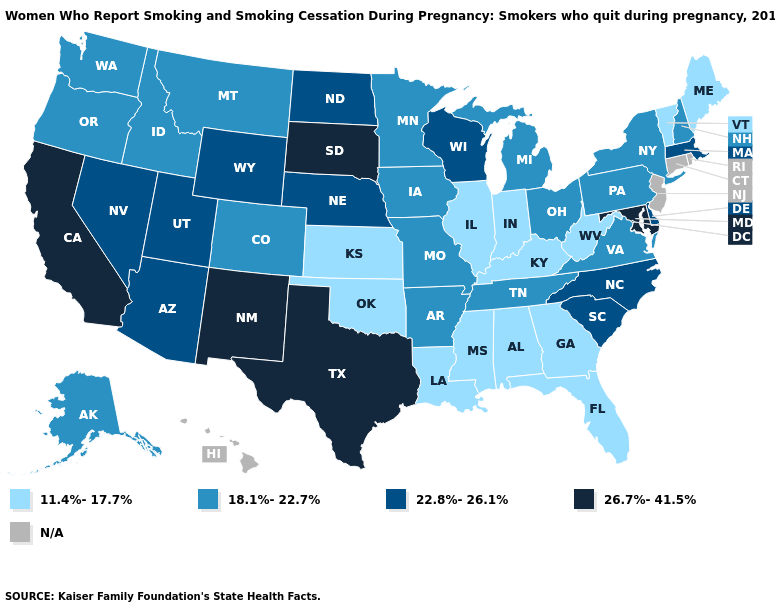What is the highest value in states that border Florida?
Be succinct. 11.4%-17.7%. Which states have the highest value in the USA?
Quick response, please. California, Maryland, New Mexico, South Dakota, Texas. Does Kentucky have the lowest value in the USA?
Give a very brief answer. Yes. What is the value of Idaho?
Answer briefly. 18.1%-22.7%. Is the legend a continuous bar?
Be succinct. No. Which states have the lowest value in the USA?
Keep it brief. Alabama, Florida, Georgia, Illinois, Indiana, Kansas, Kentucky, Louisiana, Maine, Mississippi, Oklahoma, Vermont, West Virginia. Does Nebraska have the lowest value in the MidWest?
Short answer required. No. What is the highest value in states that border Florida?
Concise answer only. 11.4%-17.7%. What is the highest value in the USA?
Answer briefly. 26.7%-41.5%. Does the map have missing data?
Concise answer only. Yes. Is the legend a continuous bar?
Write a very short answer. No. How many symbols are there in the legend?
Quick response, please. 5. Name the states that have a value in the range 26.7%-41.5%?
Answer briefly. California, Maryland, New Mexico, South Dakota, Texas. Name the states that have a value in the range 26.7%-41.5%?
Short answer required. California, Maryland, New Mexico, South Dakota, Texas. 